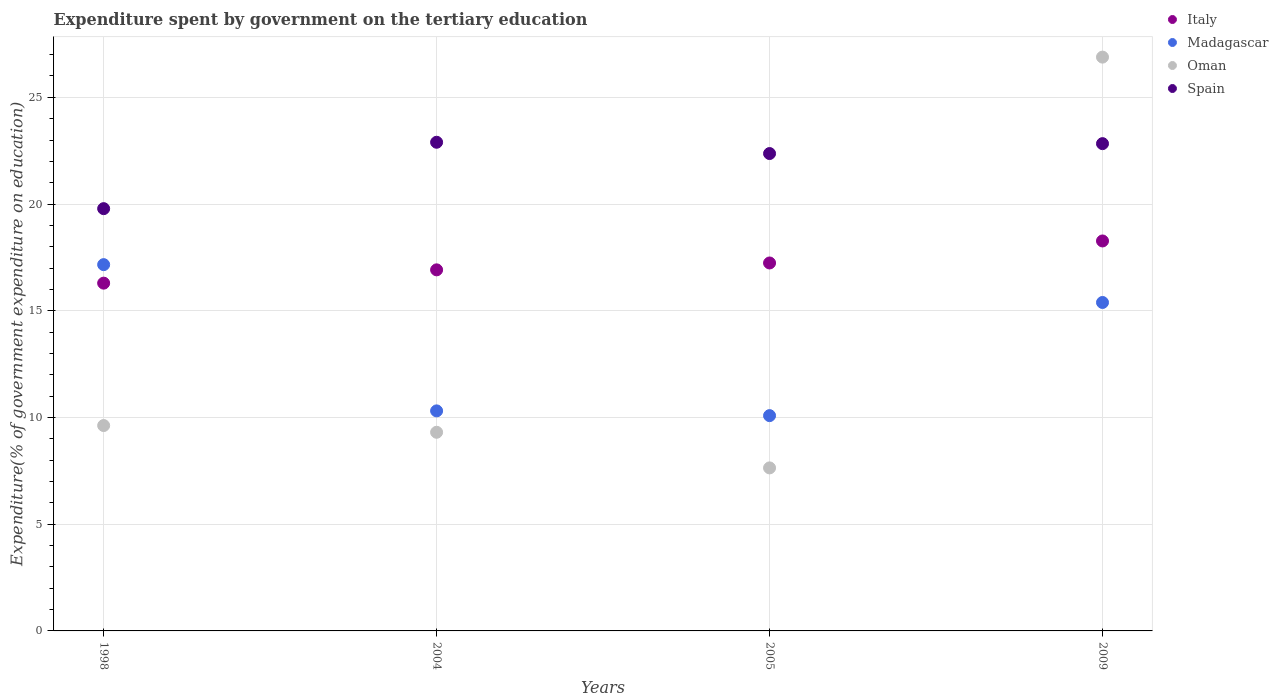How many different coloured dotlines are there?
Your answer should be compact. 4. What is the expenditure spent by government on the tertiary education in Oman in 1998?
Provide a succinct answer. 9.62. Across all years, what is the maximum expenditure spent by government on the tertiary education in Madagascar?
Your answer should be compact. 17.16. Across all years, what is the minimum expenditure spent by government on the tertiary education in Italy?
Provide a succinct answer. 16.29. In which year was the expenditure spent by government on the tertiary education in Madagascar maximum?
Offer a very short reply. 1998. In which year was the expenditure spent by government on the tertiary education in Italy minimum?
Provide a short and direct response. 1998. What is the total expenditure spent by government on the tertiary education in Oman in the graph?
Provide a short and direct response. 53.45. What is the difference between the expenditure spent by government on the tertiary education in Italy in 2004 and that in 2009?
Make the answer very short. -1.35. What is the difference between the expenditure spent by government on the tertiary education in Spain in 1998 and the expenditure spent by government on the tertiary education in Italy in 2004?
Your answer should be compact. 2.87. What is the average expenditure spent by government on the tertiary education in Spain per year?
Provide a short and direct response. 21.97. In the year 2005, what is the difference between the expenditure spent by government on the tertiary education in Madagascar and expenditure spent by government on the tertiary education in Spain?
Make the answer very short. -12.28. In how many years, is the expenditure spent by government on the tertiary education in Oman greater than 25 %?
Keep it short and to the point. 1. What is the ratio of the expenditure spent by government on the tertiary education in Oman in 2004 to that in 2005?
Give a very brief answer. 1.22. What is the difference between the highest and the second highest expenditure spent by government on the tertiary education in Italy?
Provide a succinct answer. 1.03. What is the difference between the highest and the lowest expenditure spent by government on the tertiary education in Madagascar?
Offer a very short reply. 7.07. Is it the case that in every year, the sum of the expenditure spent by government on the tertiary education in Madagascar and expenditure spent by government on the tertiary education in Spain  is greater than the sum of expenditure spent by government on the tertiary education in Oman and expenditure spent by government on the tertiary education in Italy?
Make the answer very short. No. Is it the case that in every year, the sum of the expenditure spent by government on the tertiary education in Oman and expenditure spent by government on the tertiary education in Spain  is greater than the expenditure spent by government on the tertiary education in Madagascar?
Give a very brief answer. Yes. Does the expenditure spent by government on the tertiary education in Madagascar monotonically increase over the years?
Provide a short and direct response. No. Is the expenditure spent by government on the tertiary education in Madagascar strictly less than the expenditure spent by government on the tertiary education in Oman over the years?
Your answer should be very brief. No. How many years are there in the graph?
Provide a short and direct response. 4. Does the graph contain any zero values?
Offer a terse response. No. Does the graph contain grids?
Your answer should be compact. Yes. Where does the legend appear in the graph?
Offer a terse response. Top right. How many legend labels are there?
Provide a short and direct response. 4. What is the title of the graph?
Provide a short and direct response. Expenditure spent by government on the tertiary education. Does "Kazakhstan" appear as one of the legend labels in the graph?
Provide a short and direct response. No. What is the label or title of the Y-axis?
Your answer should be compact. Expenditure(% of government expenditure on education). What is the Expenditure(% of government expenditure on education) of Italy in 1998?
Give a very brief answer. 16.29. What is the Expenditure(% of government expenditure on education) of Madagascar in 1998?
Provide a short and direct response. 17.16. What is the Expenditure(% of government expenditure on education) in Oman in 1998?
Keep it short and to the point. 9.62. What is the Expenditure(% of government expenditure on education) of Spain in 1998?
Give a very brief answer. 19.78. What is the Expenditure(% of government expenditure on education) of Italy in 2004?
Offer a terse response. 16.92. What is the Expenditure(% of government expenditure on education) in Madagascar in 2004?
Keep it short and to the point. 10.31. What is the Expenditure(% of government expenditure on education) of Oman in 2004?
Provide a short and direct response. 9.31. What is the Expenditure(% of government expenditure on education) in Spain in 2004?
Provide a short and direct response. 22.89. What is the Expenditure(% of government expenditure on education) in Italy in 2005?
Give a very brief answer. 17.24. What is the Expenditure(% of government expenditure on education) of Madagascar in 2005?
Your answer should be compact. 10.09. What is the Expenditure(% of government expenditure on education) in Oman in 2005?
Keep it short and to the point. 7.64. What is the Expenditure(% of government expenditure on education) in Spain in 2005?
Provide a short and direct response. 22.37. What is the Expenditure(% of government expenditure on education) of Italy in 2009?
Give a very brief answer. 18.27. What is the Expenditure(% of government expenditure on education) in Madagascar in 2009?
Provide a succinct answer. 15.39. What is the Expenditure(% of government expenditure on education) in Oman in 2009?
Keep it short and to the point. 26.88. What is the Expenditure(% of government expenditure on education) of Spain in 2009?
Your answer should be compact. 22.83. Across all years, what is the maximum Expenditure(% of government expenditure on education) of Italy?
Ensure brevity in your answer.  18.27. Across all years, what is the maximum Expenditure(% of government expenditure on education) of Madagascar?
Your answer should be very brief. 17.16. Across all years, what is the maximum Expenditure(% of government expenditure on education) of Oman?
Keep it short and to the point. 26.88. Across all years, what is the maximum Expenditure(% of government expenditure on education) of Spain?
Give a very brief answer. 22.89. Across all years, what is the minimum Expenditure(% of government expenditure on education) of Italy?
Offer a very short reply. 16.29. Across all years, what is the minimum Expenditure(% of government expenditure on education) in Madagascar?
Offer a very short reply. 10.09. Across all years, what is the minimum Expenditure(% of government expenditure on education) in Oman?
Offer a very short reply. 7.64. Across all years, what is the minimum Expenditure(% of government expenditure on education) in Spain?
Your answer should be compact. 19.78. What is the total Expenditure(% of government expenditure on education) of Italy in the graph?
Provide a short and direct response. 68.72. What is the total Expenditure(% of government expenditure on education) of Madagascar in the graph?
Provide a short and direct response. 52.94. What is the total Expenditure(% of government expenditure on education) of Oman in the graph?
Keep it short and to the point. 53.45. What is the total Expenditure(% of government expenditure on education) in Spain in the graph?
Your response must be concise. 87.87. What is the difference between the Expenditure(% of government expenditure on education) in Italy in 1998 and that in 2004?
Your answer should be compact. -0.62. What is the difference between the Expenditure(% of government expenditure on education) in Madagascar in 1998 and that in 2004?
Your response must be concise. 6.85. What is the difference between the Expenditure(% of government expenditure on education) of Oman in 1998 and that in 2004?
Ensure brevity in your answer.  0.32. What is the difference between the Expenditure(% of government expenditure on education) of Spain in 1998 and that in 2004?
Your answer should be very brief. -3.11. What is the difference between the Expenditure(% of government expenditure on education) of Italy in 1998 and that in 2005?
Your response must be concise. -0.95. What is the difference between the Expenditure(% of government expenditure on education) in Madagascar in 1998 and that in 2005?
Keep it short and to the point. 7.07. What is the difference between the Expenditure(% of government expenditure on education) in Oman in 1998 and that in 2005?
Provide a short and direct response. 1.98. What is the difference between the Expenditure(% of government expenditure on education) of Spain in 1998 and that in 2005?
Make the answer very short. -2.58. What is the difference between the Expenditure(% of government expenditure on education) of Italy in 1998 and that in 2009?
Your response must be concise. -1.98. What is the difference between the Expenditure(% of government expenditure on education) in Madagascar in 1998 and that in 2009?
Offer a very short reply. 1.77. What is the difference between the Expenditure(% of government expenditure on education) in Oman in 1998 and that in 2009?
Your response must be concise. -17.26. What is the difference between the Expenditure(% of government expenditure on education) of Spain in 1998 and that in 2009?
Keep it short and to the point. -3.05. What is the difference between the Expenditure(% of government expenditure on education) of Italy in 2004 and that in 2005?
Make the answer very short. -0.32. What is the difference between the Expenditure(% of government expenditure on education) of Madagascar in 2004 and that in 2005?
Offer a terse response. 0.22. What is the difference between the Expenditure(% of government expenditure on education) of Oman in 2004 and that in 2005?
Ensure brevity in your answer.  1.67. What is the difference between the Expenditure(% of government expenditure on education) in Spain in 2004 and that in 2005?
Your answer should be compact. 0.53. What is the difference between the Expenditure(% of government expenditure on education) in Italy in 2004 and that in 2009?
Your answer should be very brief. -1.35. What is the difference between the Expenditure(% of government expenditure on education) in Madagascar in 2004 and that in 2009?
Offer a very short reply. -5.08. What is the difference between the Expenditure(% of government expenditure on education) of Oman in 2004 and that in 2009?
Offer a terse response. -17.58. What is the difference between the Expenditure(% of government expenditure on education) in Spain in 2004 and that in 2009?
Ensure brevity in your answer.  0.06. What is the difference between the Expenditure(% of government expenditure on education) in Italy in 2005 and that in 2009?
Ensure brevity in your answer.  -1.03. What is the difference between the Expenditure(% of government expenditure on education) of Madagascar in 2005 and that in 2009?
Offer a very short reply. -5.3. What is the difference between the Expenditure(% of government expenditure on education) in Oman in 2005 and that in 2009?
Your response must be concise. -19.25. What is the difference between the Expenditure(% of government expenditure on education) in Spain in 2005 and that in 2009?
Make the answer very short. -0.46. What is the difference between the Expenditure(% of government expenditure on education) of Italy in 1998 and the Expenditure(% of government expenditure on education) of Madagascar in 2004?
Provide a short and direct response. 5.98. What is the difference between the Expenditure(% of government expenditure on education) in Italy in 1998 and the Expenditure(% of government expenditure on education) in Oman in 2004?
Make the answer very short. 6.99. What is the difference between the Expenditure(% of government expenditure on education) in Italy in 1998 and the Expenditure(% of government expenditure on education) in Spain in 2004?
Make the answer very short. -6.6. What is the difference between the Expenditure(% of government expenditure on education) of Madagascar in 1998 and the Expenditure(% of government expenditure on education) of Oman in 2004?
Your response must be concise. 7.85. What is the difference between the Expenditure(% of government expenditure on education) in Madagascar in 1998 and the Expenditure(% of government expenditure on education) in Spain in 2004?
Provide a short and direct response. -5.73. What is the difference between the Expenditure(% of government expenditure on education) in Oman in 1998 and the Expenditure(% of government expenditure on education) in Spain in 2004?
Make the answer very short. -13.27. What is the difference between the Expenditure(% of government expenditure on education) of Italy in 1998 and the Expenditure(% of government expenditure on education) of Madagascar in 2005?
Provide a short and direct response. 6.21. What is the difference between the Expenditure(% of government expenditure on education) of Italy in 1998 and the Expenditure(% of government expenditure on education) of Oman in 2005?
Offer a very short reply. 8.66. What is the difference between the Expenditure(% of government expenditure on education) of Italy in 1998 and the Expenditure(% of government expenditure on education) of Spain in 2005?
Make the answer very short. -6.07. What is the difference between the Expenditure(% of government expenditure on education) in Madagascar in 1998 and the Expenditure(% of government expenditure on education) in Oman in 2005?
Your answer should be compact. 9.52. What is the difference between the Expenditure(% of government expenditure on education) of Madagascar in 1998 and the Expenditure(% of government expenditure on education) of Spain in 2005?
Your answer should be compact. -5.2. What is the difference between the Expenditure(% of government expenditure on education) of Oman in 1998 and the Expenditure(% of government expenditure on education) of Spain in 2005?
Ensure brevity in your answer.  -12.74. What is the difference between the Expenditure(% of government expenditure on education) of Italy in 1998 and the Expenditure(% of government expenditure on education) of Madagascar in 2009?
Your answer should be very brief. 0.91. What is the difference between the Expenditure(% of government expenditure on education) in Italy in 1998 and the Expenditure(% of government expenditure on education) in Oman in 2009?
Your answer should be compact. -10.59. What is the difference between the Expenditure(% of government expenditure on education) in Italy in 1998 and the Expenditure(% of government expenditure on education) in Spain in 2009?
Provide a succinct answer. -6.54. What is the difference between the Expenditure(% of government expenditure on education) of Madagascar in 1998 and the Expenditure(% of government expenditure on education) of Oman in 2009?
Offer a terse response. -9.72. What is the difference between the Expenditure(% of government expenditure on education) in Madagascar in 1998 and the Expenditure(% of government expenditure on education) in Spain in 2009?
Make the answer very short. -5.67. What is the difference between the Expenditure(% of government expenditure on education) in Oman in 1998 and the Expenditure(% of government expenditure on education) in Spain in 2009?
Ensure brevity in your answer.  -13.21. What is the difference between the Expenditure(% of government expenditure on education) in Italy in 2004 and the Expenditure(% of government expenditure on education) in Madagascar in 2005?
Your answer should be compact. 6.83. What is the difference between the Expenditure(% of government expenditure on education) of Italy in 2004 and the Expenditure(% of government expenditure on education) of Oman in 2005?
Make the answer very short. 9.28. What is the difference between the Expenditure(% of government expenditure on education) in Italy in 2004 and the Expenditure(% of government expenditure on education) in Spain in 2005?
Make the answer very short. -5.45. What is the difference between the Expenditure(% of government expenditure on education) in Madagascar in 2004 and the Expenditure(% of government expenditure on education) in Oman in 2005?
Offer a very short reply. 2.67. What is the difference between the Expenditure(% of government expenditure on education) in Madagascar in 2004 and the Expenditure(% of government expenditure on education) in Spain in 2005?
Ensure brevity in your answer.  -12.06. What is the difference between the Expenditure(% of government expenditure on education) in Oman in 2004 and the Expenditure(% of government expenditure on education) in Spain in 2005?
Ensure brevity in your answer.  -13.06. What is the difference between the Expenditure(% of government expenditure on education) of Italy in 2004 and the Expenditure(% of government expenditure on education) of Madagascar in 2009?
Your answer should be very brief. 1.53. What is the difference between the Expenditure(% of government expenditure on education) of Italy in 2004 and the Expenditure(% of government expenditure on education) of Oman in 2009?
Offer a very short reply. -9.97. What is the difference between the Expenditure(% of government expenditure on education) in Italy in 2004 and the Expenditure(% of government expenditure on education) in Spain in 2009?
Your response must be concise. -5.91. What is the difference between the Expenditure(% of government expenditure on education) of Madagascar in 2004 and the Expenditure(% of government expenditure on education) of Oman in 2009?
Your answer should be compact. -16.57. What is the difference between the Expenditure(% of government expenditure on education) of Madagascar in 2004 and the Expenditure(% of government expenditure on education) of Spain in 2009?
Your answer should be very brief. -12.52. What is the difference between the Expenditure(% of government expenditure on education) of Oman in 2004 and the Expenditure(% of government expenditure on education) of Spain in 2009?
Give a very brief answer. -13.52. What is the difference between the Expenditure(% of government expenditure on education) in Italy in 2005 and the Expenditure(% of government expenditure on education) in Madagascar in 2009?
Provide a succinct answer. 1.85. What is the difference between the Expenditure(% of government expenditure on education) of Italy in 2005 and the Expenditure(% of government expenditure on education) of Oman in 2009?
Your answer should be compact. -9.64. What is the difference between the Expenditure(% of government expenditure on education) of Italy in 2005 and the Expenditure(% of government expenditure on education) of Spain in 2009?
Offer a very short reply. -5.59. What is the difference between the Expenditure(% of government expenditure on education) of Madagascar in 2005 and the Expenditure(% of government expenditure on education) of Oman in 2009?
Offer a terse response. -16.8. What is the difference between the Expenditure(% of government expenditure on education) in Madagascar in 2005 and the Expenditure(% of government expenditure on education) in Spain in 2009?
Ensure brevity in your answer.  -12.74. What is the difference between the Expenditure(% of government expenditure on education) in Oman in 2005 and the Expenditure(% of government expenditure on education) in Spain in 2009?
Your response must be concise. -15.19. What is the average Expenditure(% of government expenditure on education) of Italy per year?
Your answer should be very brief. 17.18. What is the average Expenditure(% of government expenditure on education) in Madagascar per year?
Make the answer very short. 13.24. What is the average Expenditure(% of government expenditure on education) in Oman per year?
Provide a succinct answer. 13.36. What is the average Expenditure(% of government expenditure on education) in Spain per year?
Your answer should be compact. 21.97. In the year 1998, what is the difference between the Expenditure(% of government expenditure on education) in Italy and Expenditure(% of government expenditure on education) in Madagascar?
Provide a short and direct response. -0.87. In the year 1998, what is the difference between the Expenditure(% of government expenditure on education) in Italy and Expenditure(% of government expenditure on education) in Oman?
Make the answer very short. 6.67. In the year 1998, what is the difference between the Expenditure(% of government expenditure on education) in Italy and Expenditure(% of government expenditure on education) in Spain?
Your answer should be compact. -3.49. In the year 1998, what is the difference between the Expenditure(% of government expenditure on education) of Madagascar and Expenditure(% of government expenditure on education) of Oman?
Offer a terse response. 7.54. In the year 1998, what is the difference between the Expenditure(% of government expenditure on education) in Madagascar and Expenditure(% of government expenditure on education) in Spain?
Your answer should be compact. -2.62. In the year 1998, what is the difference between the Expenditure(% of government expenditure on education) in Oman and Expenditure(% of government expenditure on education) in Spain?
Give a very brief answer. -10.16. In the year 2004, what is the difference between the Expenditure(% of government expenditure on education) of Italy and Expenditure(% of government expenditure on education) of Madagascar?
Your answer should be compact. 6.61. In the year 2004, what is the difference between the Expenditure(% of government expenditure on education) of Italy and Expenditure(% of government expenditure on education) of Oman?
Provide a short and direct response. 7.61. In the year 2004, what is the difference between the Expenditure(% of government expenditure on education) of Italy and Expenditure(% of government expenditure on education) of Spain?
Your response must be concise. -5.98. In the year 2004, what is the difference between the Expenditure(% of government expenditure on education) of Madagascar and Expenditure(% of government expenditure on education) of Spain?
Ensure brevity in your answer.  -12.59. In the year 2004, what is the difference between the Expenditure(% of government expenditure on education) in Oman and Expenditure(% of government expenditure on education) in Spain?
Offer a terse response. -13.59. In the year 2005, what is the difference between the Expenditure(% of government expenditure on education) in Italy and Expenditure(% of government expenditure on education) in Madagascar?
Make the answer very short. 7.15. In the year 2005, what is the difference between the Expenditure(% of government expenditure on education) in Italy and Expenditure(% of government expenditure on education) in Oman?
Your response must be concise. 9.6. In the year 2005, what is the difference between the Expenditure(% of government expenditure on education) of Italy and Expenditure(% of government expenditure on education) of Spain?
Your answer should be compact. -5.13. In the year 2005, what is the difference between the Expenditure(% of government expenditure on education) of Madagascar and Expenditure(% of government expenditure on education) of Oman?
Offer a terse response. 2.45. In the year 2005, what is the difference between the Expenditure(% of government expenditure on education) in Madagascar and Expenditure(% of government expenditure on education) in Spain?
Ensure brevity in your answer.  -12.28. In the year 2005, what is the difference between the Expenditure(% of government expenditure on education) in Oman and Expenditure(% of government expenditure on education) in Spain?
Provide a succinct answer. -14.73. In the year 2009, what is the difference between the Expenditure(% of government expenditure on education) in Italy and Expenditure(% of government expenditure on education) in Madagascar?
Your response must be concise. 2.88. In the year 2009, what is the difference between the Expenditure(% of government expenditure on education) in Italy and Expenditure(% of government expenditure on education) in Oman?
Ensure brevity in your answer.  -8.61. In the year 2009, what is the difference between the Expenditure(% of government expenditure on education) in Italy and Expenditure(% of government expenditure on education) in Spain?
Offer a very short reply. -4.56. In the year 2009, what is the difference between the Expenditure(% of government expenditure on education) in Madagascar and Expenditure(% of government expenditure on education) in Oman?
Provide a succinct answer. -11.5. In the year 2009, what is the difference between the Expenditure(% of government expenditure on education) of Madagascar and Expenditure(% of government expenditure on education) of Spain?
Make the answer very short. -7.44. In the year 2009, what is the difference between the Expenditure(% of government expenditure on education) in Oman and Expenditure(% of government expenditure on education) in Spain?
Your response must be concise. 4.05. What is the ratio of the Expenditure(% of government expenditure on education) in Italy in 1998 to that in 2004?
Your response must be concise. 0.96. What is the ratio of the Expenditure(% of government expenditure on education) of Madagascar in 1998 to that in 2004?
Ensure brevity in your answer.  1.66. What is the ratio of the Expenditure(% of government expenditure on education) in Oman in 1998 to that in 2004?
Give a very brief answer. 1.03. What is the ratio of the Expenditure(% of government expenditure on education) of Spain in 1998 to that in 2004?
Provide a short and direct response. 0.86. What is the ratio of the Expenditure(% of government expenditure on education) of Italy in 1998 to that in 2005?
Offer a terse response. 0.95. What is the ratio of the Expenditure(% of government expenditure on education) in Madagascar in 1998 to that in 2005?
Offer a very short reply. 1.7. What is the ratio of the Expenditure(% of government expenditure on education) in Oman in 1998 to that in 2005?
Give a very brief answer. 1.26. What is the ratio of the Expenditure(% of government expenditure on education) of Spain in 1998 to that in 2005?
Provide a succinct answer. 0.88. What is the ratio of the Expenditure(% of government expenditure on education) in Italy in 1998 to that in 2009?
Offer a very short reply. 0.89. What is the ratio of the Expenditure(% of government expenditure on education) in Madagascar in 1998 to that in 2009?
Give a very brief answer. 1.12. What is the ratio of the Expenditure(% of government expenditure on education) in Oman in 1998 to that in 2009?
Ensure brevity in your answer.  0.36. What is the ratio of the Expenditure(% of government expenditure on education) of Spain in 1998 to that in 2009?
Offer a very short reply. 0.87. What is the ratio of the Expenditure(% of government expenditure on education) of Italy in 2004 to that in 2005?
Ensure brevity in your answer.  0.98. What is the ratio of the Expenditure(% of government expenditure on education) in Madagascar in 2004 to that in 2005?
Offer a terse response. 1.02. What is the ratio of the Expenditure(% of government expenditure on education) of Oman in 2004 to that in 2005?
Provide a short and direct response. 1.22. What is the ratio of the Expenditure(% of government expenditure on education) of Spain in 2004 to that in 2005?
Your answer should be very brief. 1.02. What is the ratio of the Expenditure(% of government expenditure on education) in Italy in 2004 to that in 2009?
Offer a very short reply. 0.93. What is the ratio of the Expenditure(% of government expenditure on education) in Madagascar in 2004 to that in 2009?
Give a very brief answer. 0.67. What is the ratio of the Expenditure(% of government expenditure on education) in Oman in 2004 to that in 2009?
Keep it short and to the point. 0.35. What is the ratio of the Expenditure(% of government expenditure on education) of Italy in 2005 to that in 2009?
Provide a short and direct response. 0.94. What is the ratio of the Expenditure(% of government expenditure on education) in Madagascar in 2005 to that in 2009?
Ensure brevity in your answer.  0.66. What is the ratio of the Expenditure(% of government expenditure on education) in Oman in 2005 to that in 2009?
Provide a succinct answer. 0.28. What is the ratio of the Expenditure(% of government expenditure on education) of Spain in 2005 to that in 2009?
Provide a succinct answer. 0.98. What is the difference between the highest and the second highest Expenditure(% of government expenditure on education) of Italy?
Provide a succinct answer. 1.03. What is the difference between the highest and the second highest Expenditure(% of government expenditure on education) in Madagascar?
Ensure brevity in your answer.  1.77. What is the difference between the highest and the second highest Expenditure(% of government expenditure on education) in Oman?
Your answer should be compact. 17.26. What is the difference between the highest and the second highest Expenditure(% of government expenditure on education) of Spain?
Provide a short and direct response. 0.06. What is the difference between the highest and the lowest Expenditure(% of government expenditure on education) of Italy?
Offer a very short reply. 1.98. What is the difference between the highest and the lowest Expenditure(% of government expenditure on education) in Madagascar?
Keep it short and to the point. 7.07. What is the difference between the highest and the lowest Expenditure(% of government expenditure on education) of Oman?
Provide a short and direct response. 19.25. What is the difference between the highest and the lowest Expenditure(% of government expenditure on education) in Spain?
Provide a succinct answer. 3.11. 